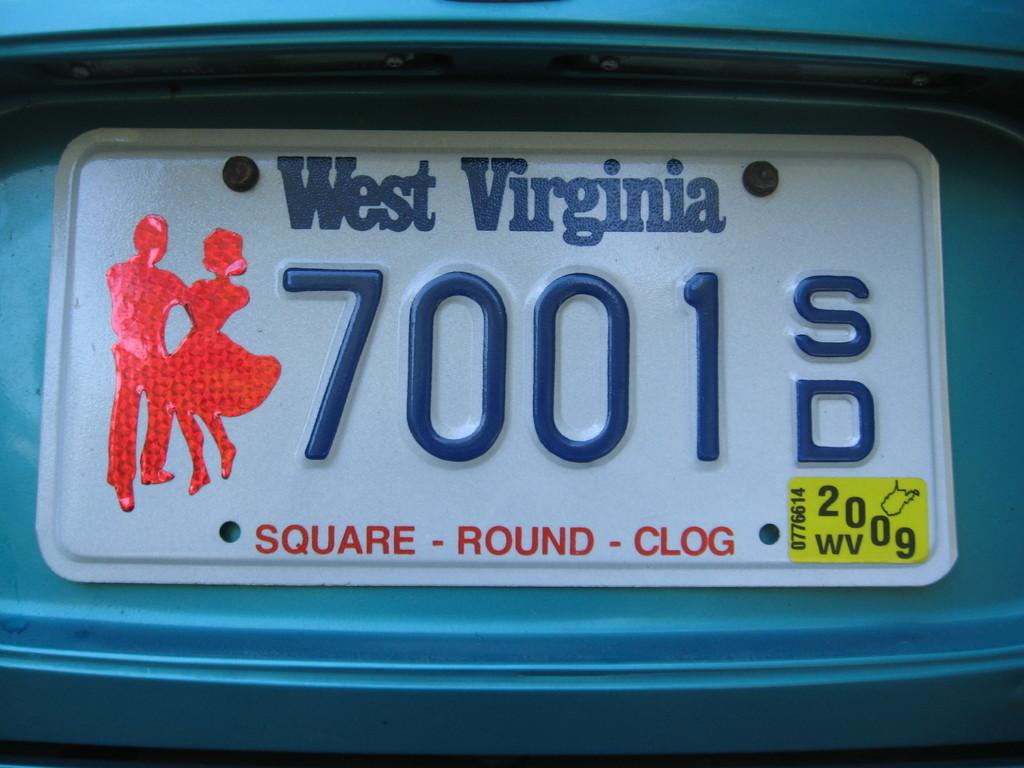Provide a one-sentence caption for the provided image. a west virginia sign that has 700 on it. 